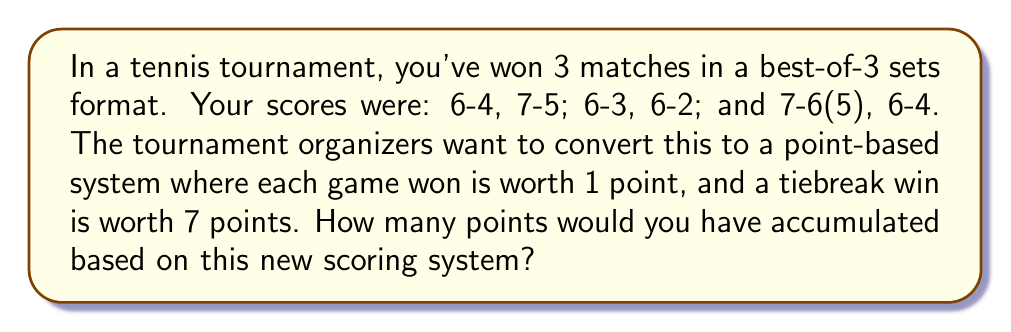Can you solve this math problem? Let's break this down match by match:

1. Match 1: 6-4, 7-5
   Points = $(6+7) = 13$

2. Match 2: 6-3, 6-2
   Points = $(6+6) = 12$

3. Match 3: 7-6(5), 6-4
   For the first set, we need to account for the tiebreak. A 7-6 score means 6 games were won in regular play, plus 7 points for winning the tiebreak.
   Points = $(6+7+6) = 19$

Now, let's sum up the points from all matches:

$$ \text{Total Points} = 13 + 12 + 19 = 44 $$

Therefore, under this new point-based scoring system, you would have accumulated 44 points from your three matches.
Answer: 44 points 